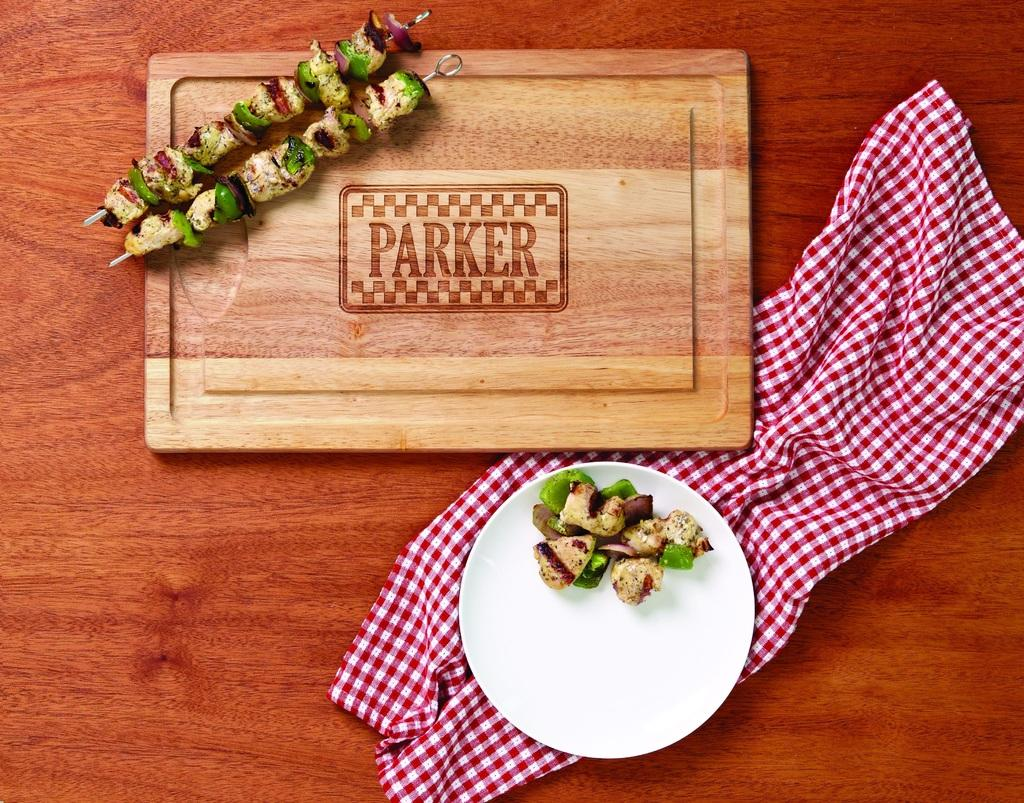What is on the white plate in the image? There are skewers on a white plate in the image. What other item can be seen in the image related to food preparation? There is a chopping board in the image. What type of napkin is present in the image? There is a white and red checkered napkin in the image. On what surface is the napkin placed? The napkin is on a wooden surface. How many hooks are hanging from the wooden surface in the image? There are no hooks visible in the image; it features a white and red checkered napkin on a wooden surface. What type of geese can be seen walking on the chopping board in the image? There are no geese present in the image; it only features skewers on a white plate, a chopping board, and a white and red checkered napkin on a wooden surface. 